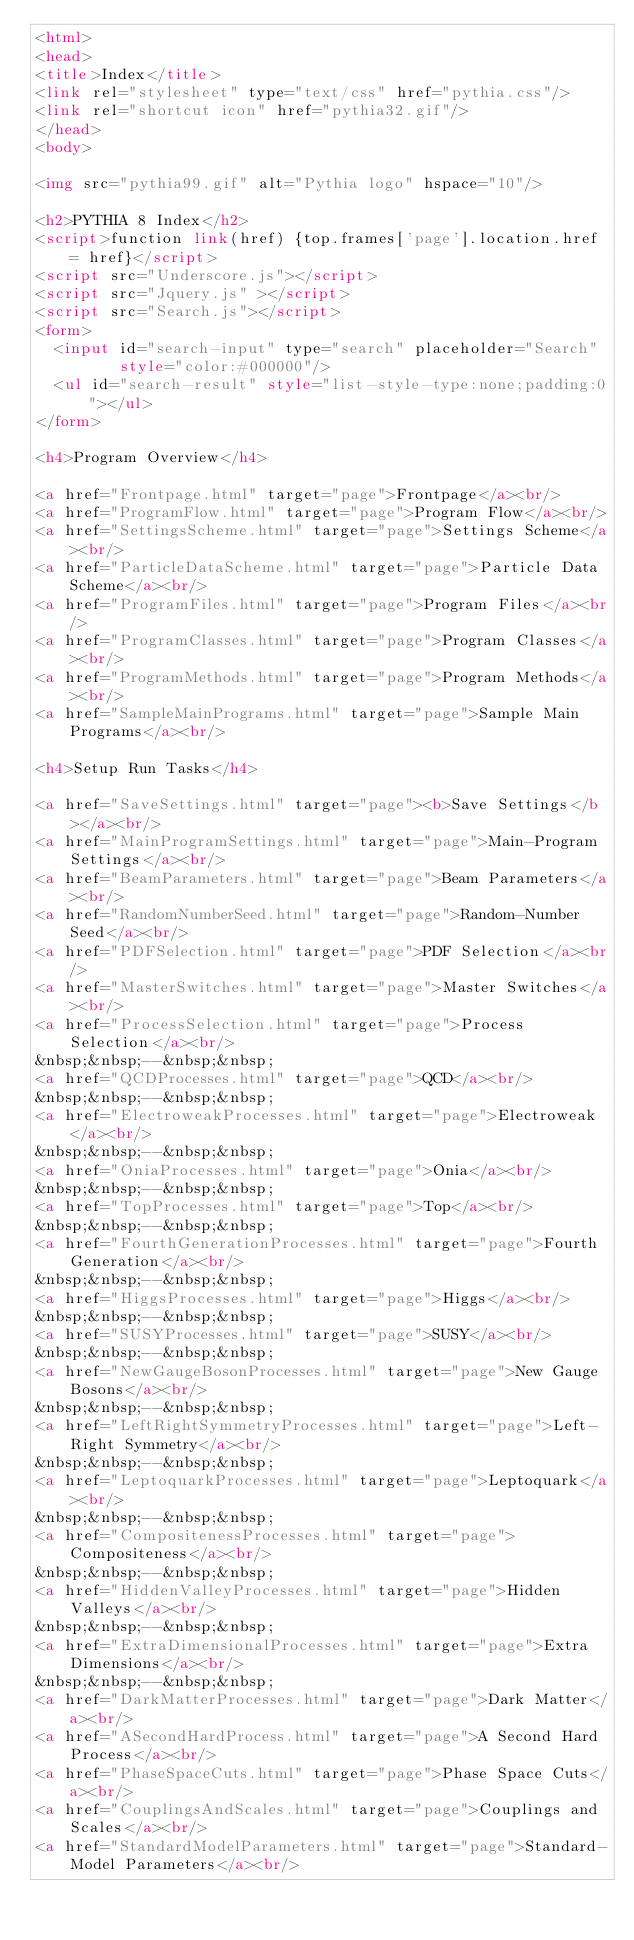Convert code to text. <code><loc_0><loc_0><loc_500><loc_500><_HTML_><html>
<head>
<title>Index</title>
<link rel="stylesheet" type="text/css" href="pythia.css"/>
<link rel="shortcut icon" href="pythia32.gif"/>
</head>
<body>
 
<img src="pythia99.gif" alt="Pythia logo" hspace="10"/> 
 
<h2>PYTHIA 8 Index</h2> 
<script>function link(href) {top.frames['page'].location.href = href}</script> 
<script src="Underscore.js"></script> 
<script src="Jquery.js" ></script> 
<script src="Search.js"></script> 
<form> 
  <input id="search-input" type="search" placeholder="Search" 
         style="color:#000000"/> 
  <ul id="search-result" style="list-style-type:none;padding:0"></ul> 
</form> 
 
<h4>Program Overview</h4> 
 
<a href="Frontpage.html" target="page">Frontpage</a><br/> 
<a href="ProgramFlow.html" target="page">Program Flow</a><br/> 
<a href="SettingsScheme.html" target="page">Settings Scheme</a><br/> 
<a href="ParticleDataScheme.html" target="page">Particle Data Scheme</a><br/> 
<a href="ProgramFiles.html" target="page">Program Files</a><br/> 
<a href="ProgramClasses.html" target="page">Program Classes</a><br/> 
<a href="ProgramMethods.html" target="page">Program Methods</a><br/> 
<a href="SampleMainPrograms.html" target="page">Sample Main Programs</a><br/> 
 
<h4>Setup Run Tasks</h4> 
 
<a href="SaveSettings.html" target="page"><b>Save Settings</b></a><br/> 
<a href="MainProgramSettings.html" target="page">Main-Program Settings</a><br/> 
<a href="BeamParameters.html" target="page">Beam Parameters</a><br/> 
<a href="RandomNumberSeed.html" target="page">Random-Number Seed</a><br/> 
<a href="PDFSelection.html" target="page">PDF Selection</a><br/> 
<a href="MasterSwitches.html" target="page">Master Switches</a><br/> 
<a href="ProcessSelection.html" target="page">Process Selection</a><br/> 
&nbsp;&nbsp;--&nbsp;&nbsp; 
<a href="QCDProcesses.html" target="page">QCD</a><br/> 
&nbsp;&nbsp;--&nbsp;&nbsp; 
<a href="ElectroweakProcesses.html" target="page">Electroweak</a><br/> 
&nbsp;&nbsp;--&nbsp;&nbsp; 
<a href="OniaProcesses.html" target="page">Onia</a><br/> 
&nbsp;&nbsp;--&nbsp;&nbsp; 
<a href="TopProcesses.html" target="page">Top</a><br/> 
&nbsp;&nbsp;--&nbsp;&nbsp; 
<a href="FourthGenerationProcesses.html" target="page">Fourth Generation</a><br/> 
&nbsp;&nbsp;--&nbsp;&nbsp; 
<a href="HiggsProcesses.html" target="page">Higgs</a><br/> 
&nbsp;&nbsp;--&nbsp;&nbsp; 
<a href="SUSYProcesses.html" target="page">SUSY</a><br/> 
&nbsp;&nbsp;--&nbsp;&nbsp; 
<a href="NewGaugeBosonProcesses.html" target="page">New Gauge Bosons</a><br/> 
&nbsp;&nbsp;--&nbsp;&nbsp; 
<a href="LeftRightSymmetryProcesses.html" target="page">Left-Right Symmetry</a><br/> 
&nbsp;&nbsp;--&nbsp;&nbsp; 
<a href="LeptoquarkProcesses.html" target="page">Leptoquark</a><br/> 
&nbsp;&nbsp;--&nbsp;&nbsp; 
<a href="CompositenessProcesses.html" target="page">Compositeness</a><br/> 
&nbsp;&nbsp;--&nbsp;&nbsp; 
<a href="HiddenValleyProcesses.html" target="page">Hidden Valleys</a><br/> 
&nbsp;&nbsp;--&nbsp;&nbsp; 
<a href="ExtraDimensionalProcesses.html" target="page">Extra Dimensions</a><br/> 
&nbsp;&nbsp;--&nbsp;&nbsp; 
<a href="DarkMatterProcesses.html" target="page">Dark Matter</a><br/> 
<a href="ASecondHardProcess.html" target="page">A Second Hard Process</a><br/> 
<a href="PhaseSpaceCuts.html" target="page">Phase Space Cuts</a><br/> 
<a href="CouplingsAndScales.html" target="page">Couplings and Scales</a><br/> 
<a href="StandardModelParameters.html" target="page">Standard-Model Parameters</a><br/> </code> 